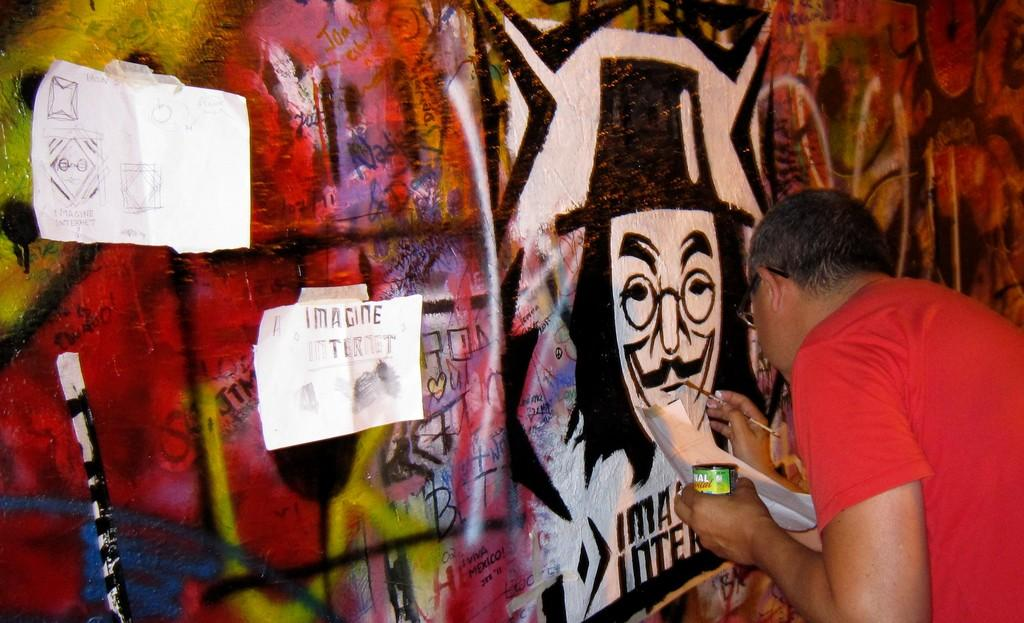What is the person in the image doing? The person is painting on a wall. What might the person be using to paint? The person is holding some papers and an object, which could be painting supplies. What else can be seen in the image besides the person painting? There are posters visible in the image. What type of oatmeal is the person eating while painting in the image? There is no oatmeal present in the image; the person is painting on a wall. Why is the crow in the image crying while the person paints? There is no crow present in the image, so it cannot be crying or interacting with the person who is painting. 